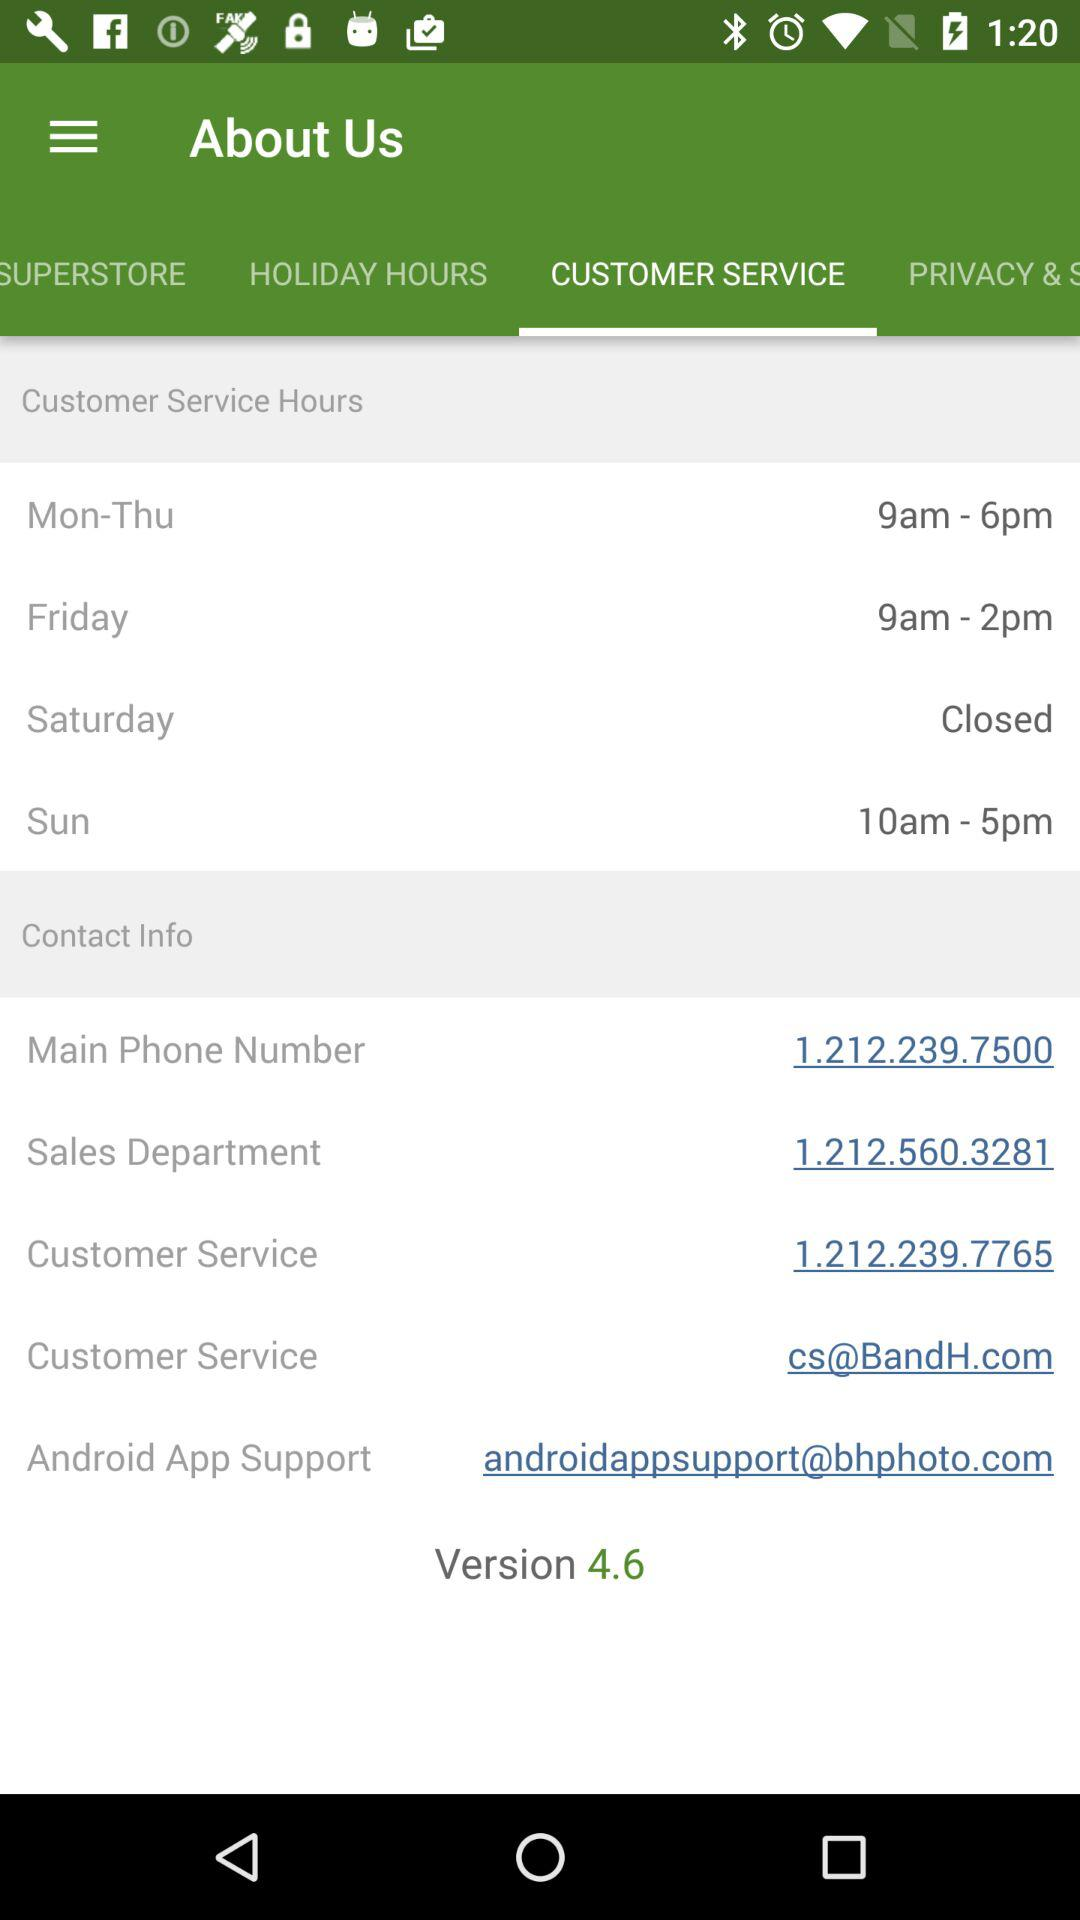When is customer service closed? Customer service is closed on Saturday. 